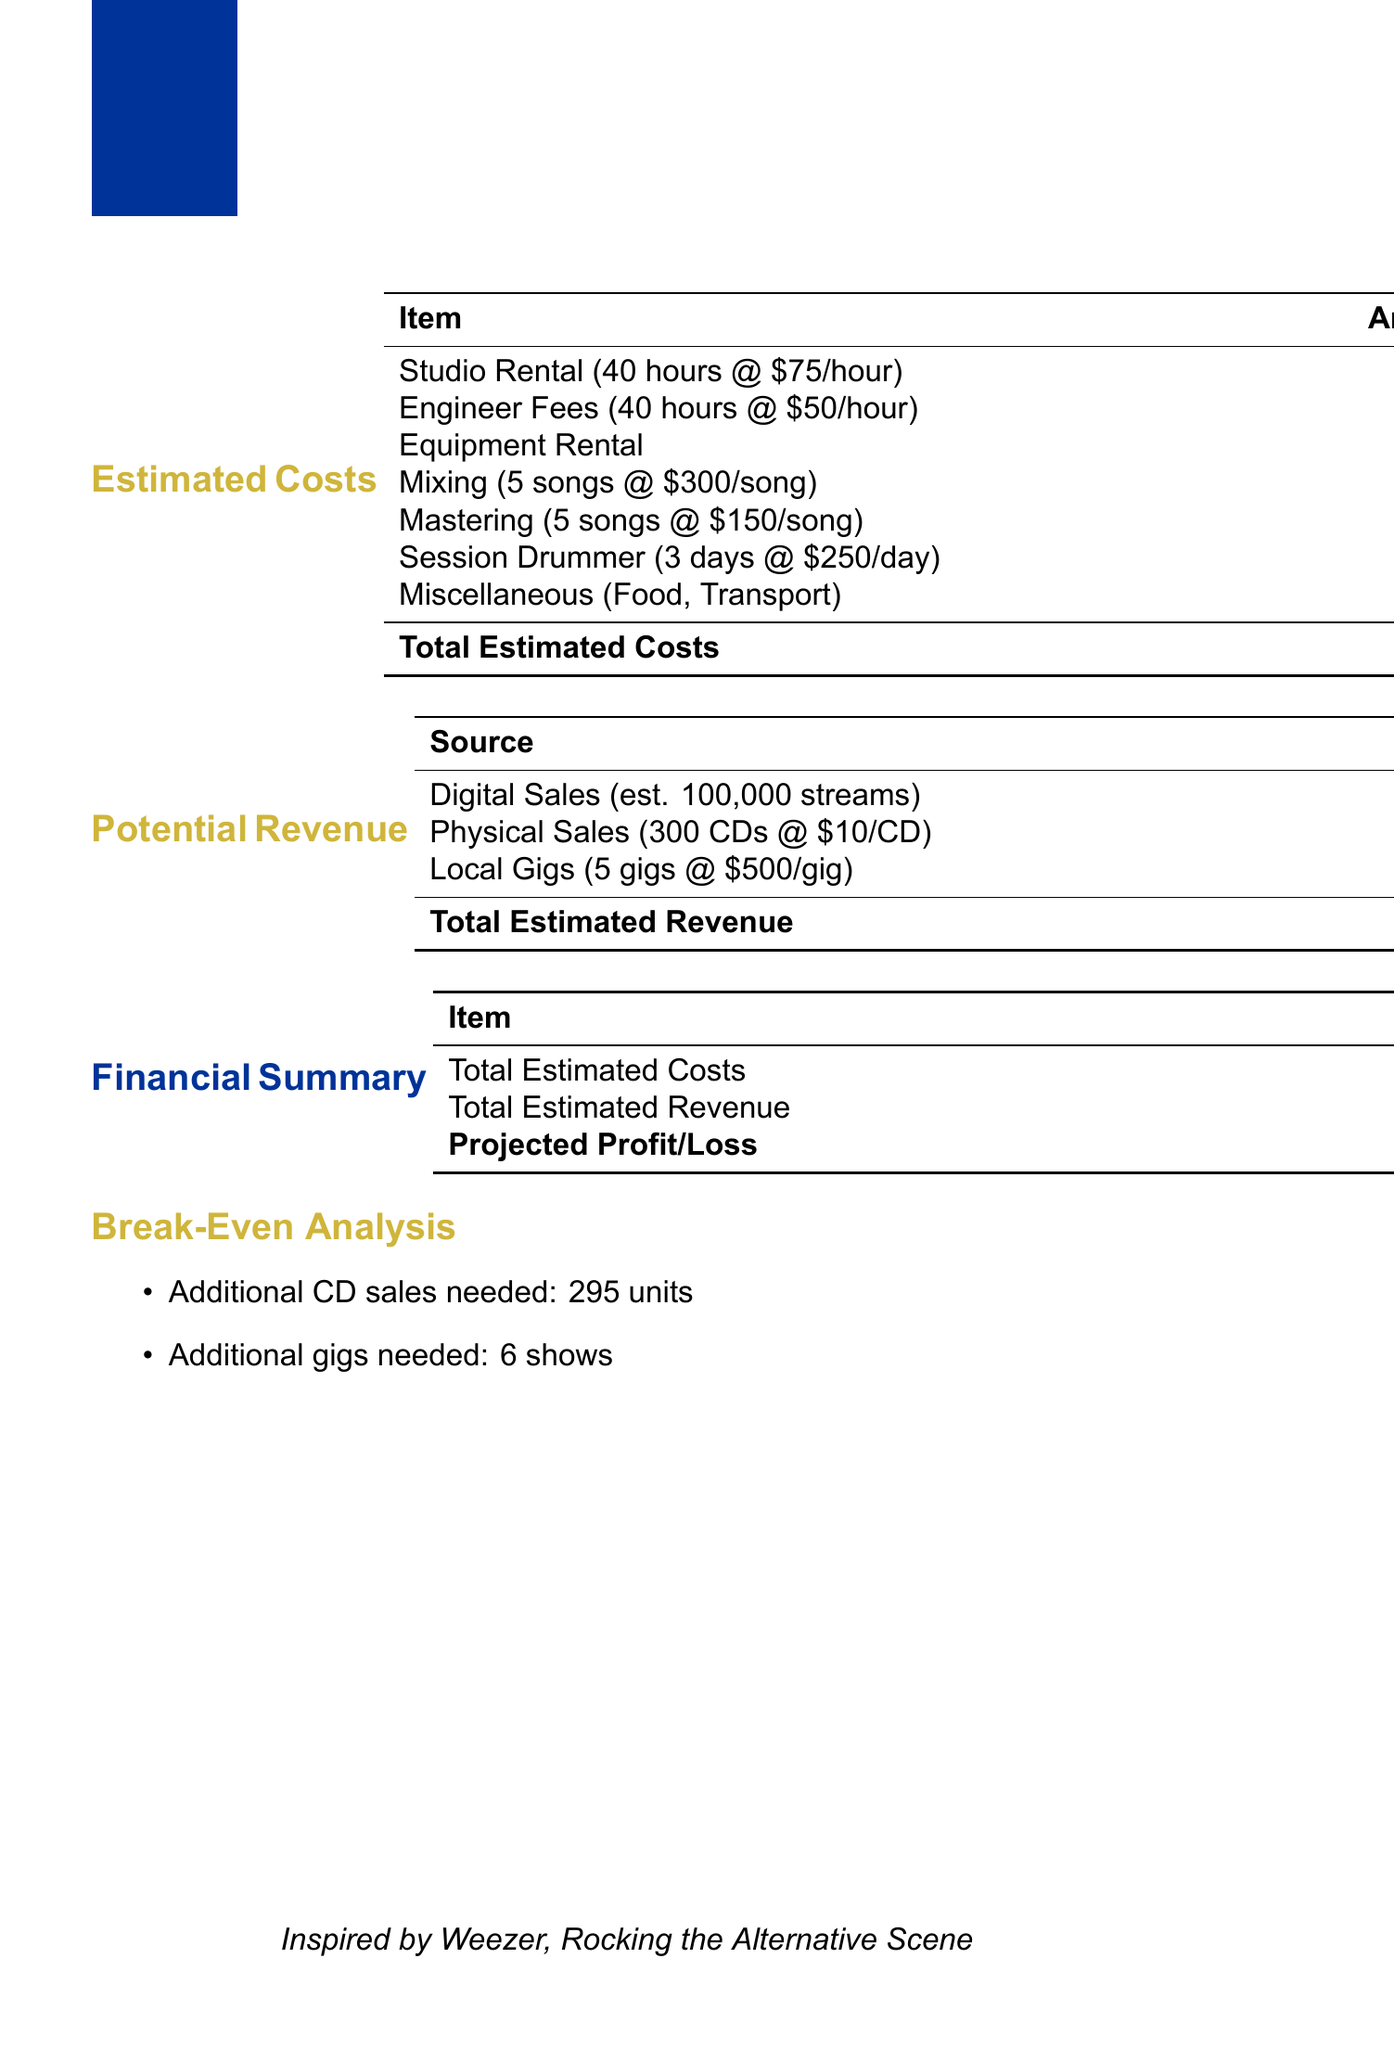What is the total estimated cost? The total estimated cost is clearly stated at the end of the cost section in the document.
Answer: 8850 What is the hourly rate for studio rental? The document specifies the hourly rate for studio rental in the detailed cost breakdown.
Answer: 75 How many songs are included in the mixing cost? The number of songs included in the mixing cost is provided directly within the production costs section.
Answer: 5 What is the estimated revenue from digital sales? The estimated revenue from digital sales is listed in the potential revenue section of the document.
Answer: 400 How many gigs are estimated for local earnings? The estimated number of local gigs is detailed in the local gigs revenue section.
Answer: 5 What is the daily rate for the session drummer? The daily rate for the session drummer is mentioned in the musician fees section of the document.
Answer: 250 What is the projected profit or loss? The projected profit or loss summarizes the financial outcome and is located in the financial summary section.
Answer: -2950 How many additional CD sales are needed to break even? The document provides a break-even analysis that lists the number of additional CD sales needed.
Answer: 295 What is the total estimated revenue? The total estimated revenue is calculated from various sources and can be found in the potential revenue section.
Answer: 5900 